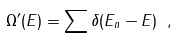Convert formula to latex. <formula><loc_0><loc_0><loc_500><loc_500>\Omega ^ { \prime } ( E ) = \sum \delta ( E _ { n } - E ) \ ,</formula> 